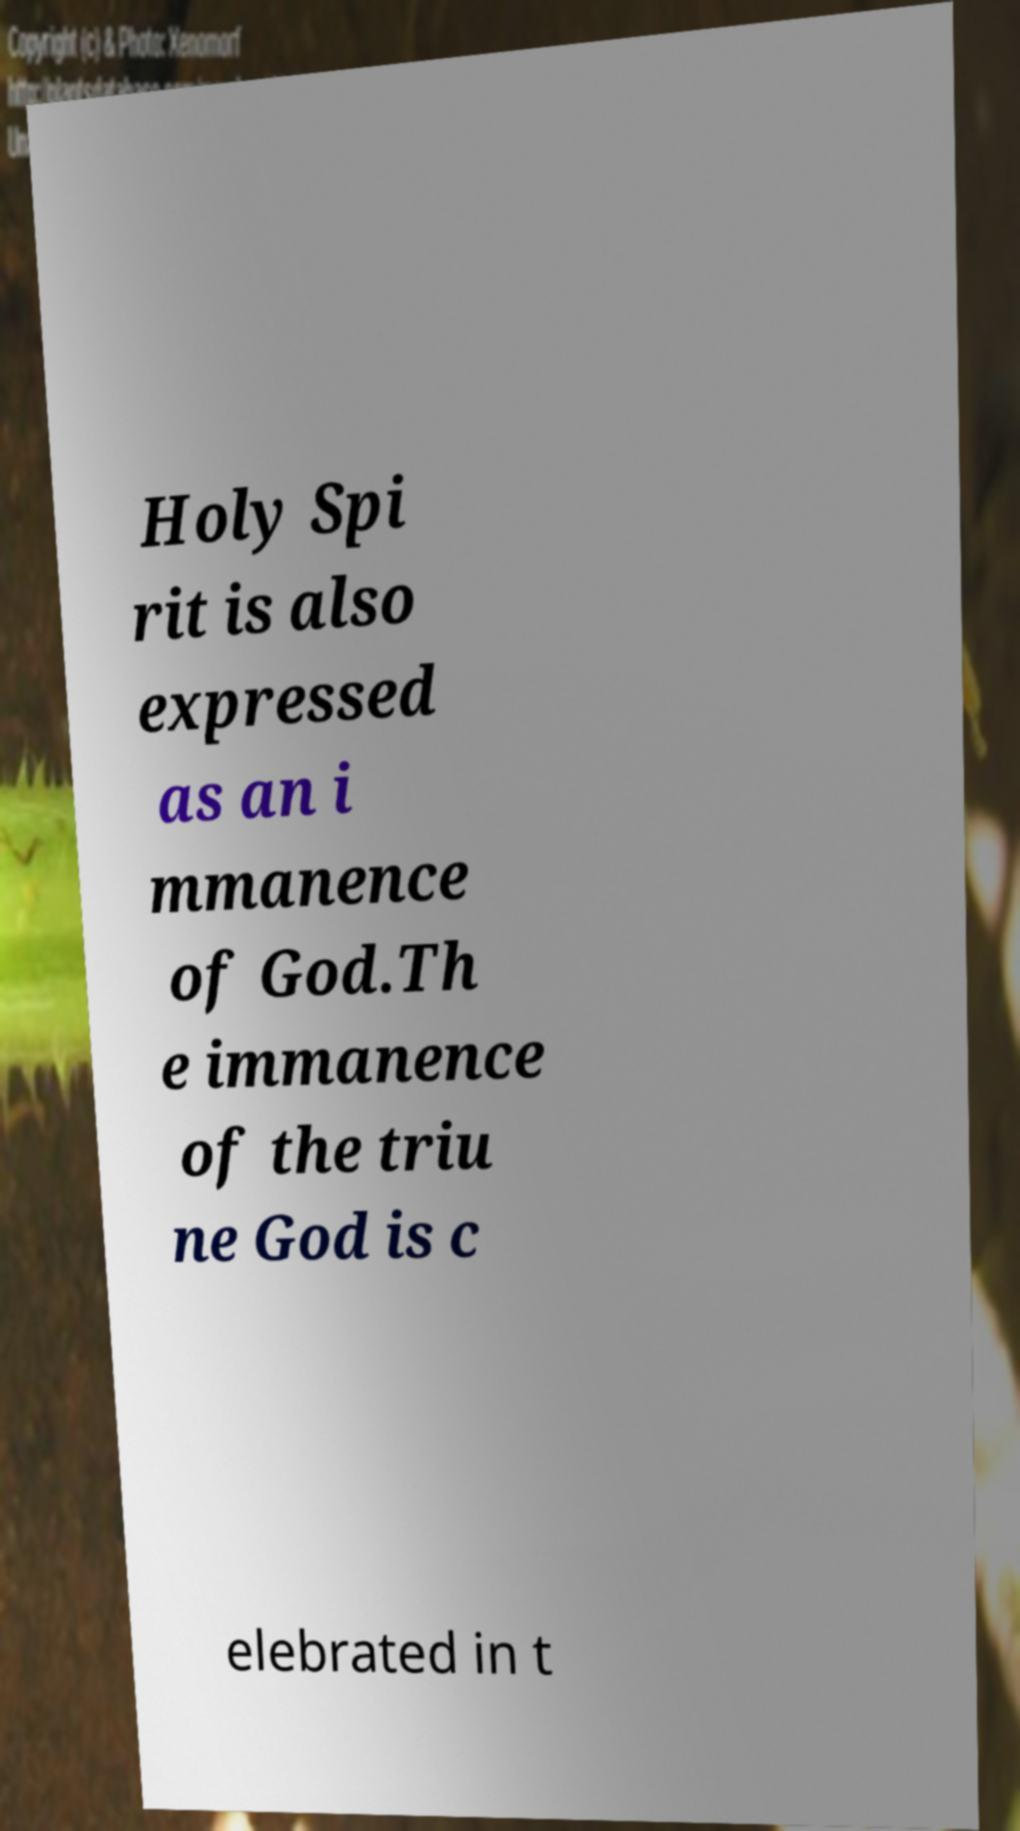Please read and relay the text visible in this image. What does it say? Holy Spi rit is also expressed as an i mmanence of God.Th e immanence of the triu ne God is c elebrated in t 